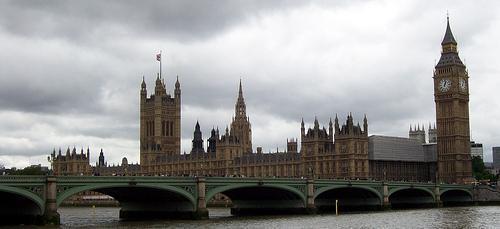How many bridges are there?
Give a very brief answer. 1. 